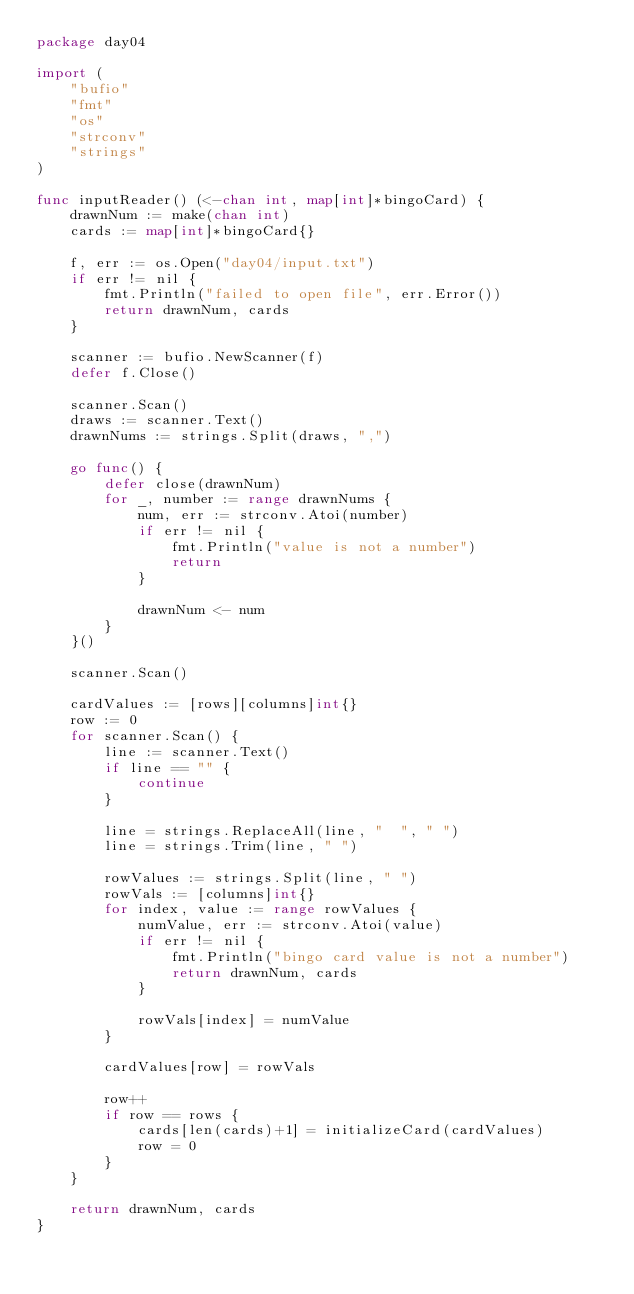Convert code to text. <code><loc_0><loc_0><loc_500><loc_500><_Go_>package day04

import (
	"bufio"
	"fmt"
	"os"
	"strconv"
	"strings"
)

func inputReader() (<-chan int, map[int]*bingoCard) {
	drawnNum := make(chan int)
	cards := map[int]*bingoCard{}

	f, err := os.Open("day04/input.txt")
	if err != nil {
		fmt.Println("failed to open file", err.Error())
		return drawnNum, cards
	}

	scanner := bufio.NewScanner(f)
	defer f.Close()

	scanner.Scan()
	draws := scanner.Text()
	drawnNums := strings.Split(draws, ",")

	go func() {
		defer close(drawnNum)
		for _, number := range drawnNums {
			num, err := strconv.Atoi(number)
			if err != nil {
				fmt.Println("value is not a number")
				return
			}

			drawnNum <- num
		}
	}()

	scanner.Scan()

	cardValues := [rows][columns]int{}
	row := 0
	for scanner.Scan() {
		line := scanner.Text()
		if line == "" {
			continue
		}

		line = strings.ReplaceAll(line, "  ", " ")
		line = strings.Trim(line, " ")

		rowValues := strings.Split(line, " ")
		rowVals := [columns]int{}
		for index, value := range rowValues {
			numValue, err := strconv.Atoi(value)
			if err != nil {
				fmt.Println("bingo card value is not a number")
				return drawnNum, cards
			}

			rowVals[index] = numValue
		}

		cardValues[row] = rowVals

		row++
		if row == rows {
			cards[len(cards)+1] = initializeCard(cardValues)
			row = 0
		}
	}

	return drawnNum, cards
}
</code> 